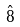<formula> <loc_0><loc_0><loc_500><loc_500>\hat { 8 }</formula> 